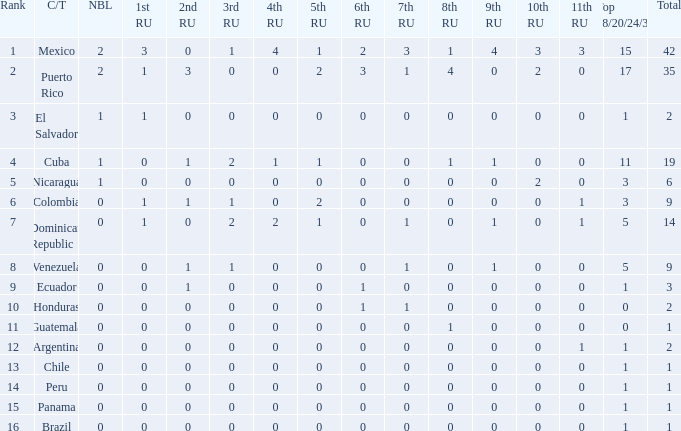What is the lowest 7th runner-up of the country with a top 18/20/24/30 greater than 5, a 1st runner-up greater than 0, and an 11th runner-up less than 0? None. 